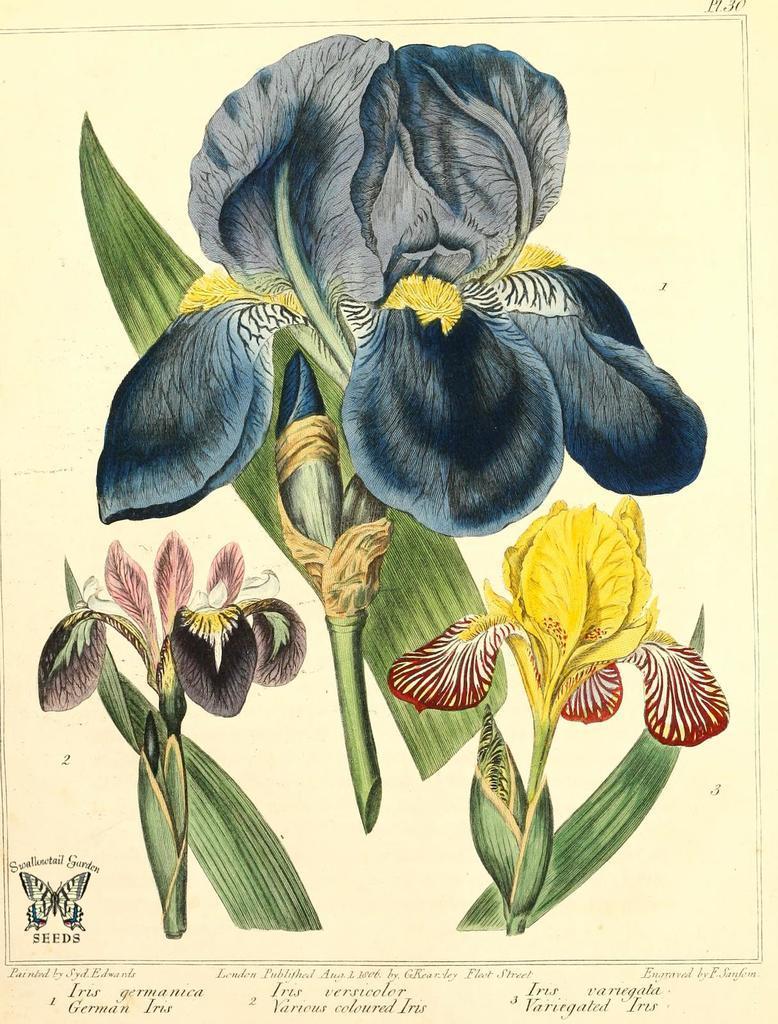Describe this image in one or two sentences. In this image, we can see there is a sheet having paintings of three plants and a butterfly, and there are texts. And the background of this sheet is cream in color. 